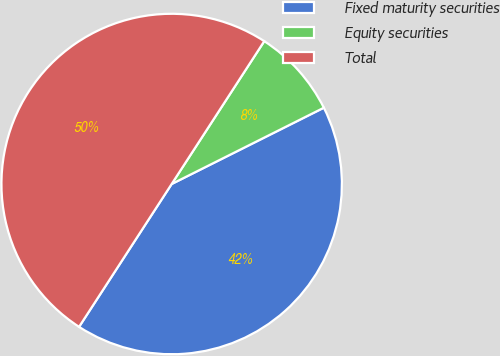<chart> <loc_0><loc_0><loc_500><loc_500><pie_chart><fcel>Fixed maturity securities<fcel>Equity securities<fcel>Total<nl><fcel>41.55%<fcel>8.45%<fcel>50.0%<nl></chart> 